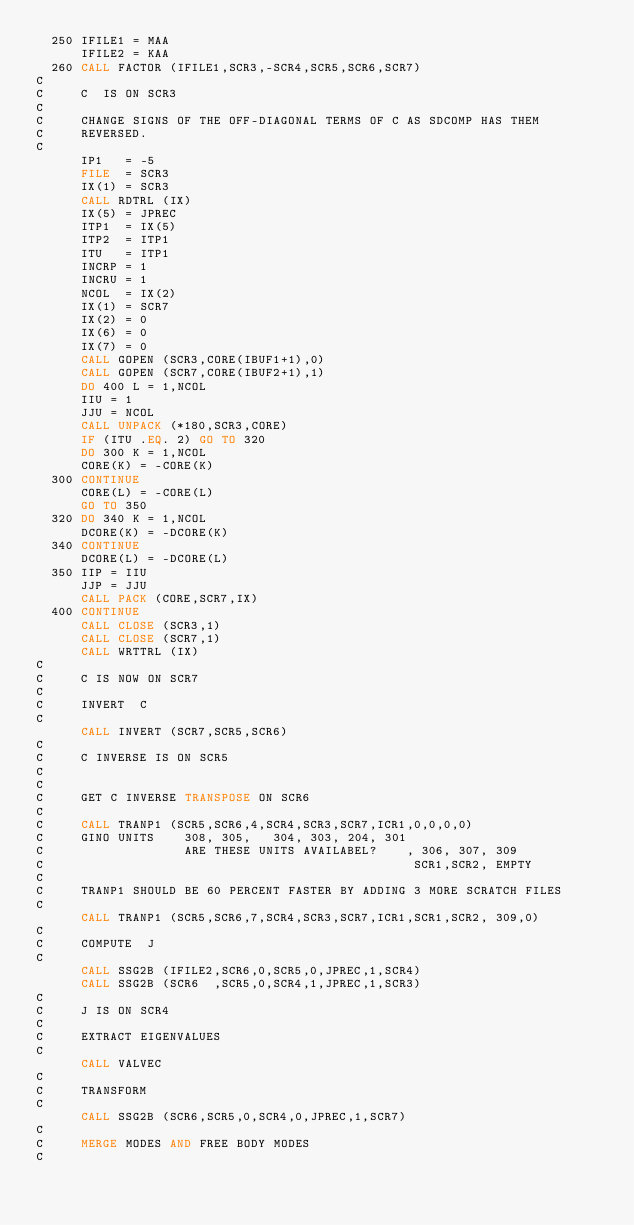Convert code to text. <code><loc_0><loc_0><loc_500><loc_500><_FORTRAN_>  250 IFILE1 = MAA
      IFILE2 = KAA
  260 CALL FACTOR (IFILE1,SCR3,-SCR4,SCR5,SCR6,SCR7)
C
C     C  IS ON SCR3
C
C     CHANGE SIGNS OF THE OFF-DIAGONAL TERMS OF C AS SDCOMP HAS THEM
C     REVERSED.
C
      IP1   = -5
      FILE  = SCR3
      IX(1) = SCR3
      CALL RDTRL (IX)
      IX(5) = JPREC
      ITP1  = IX(5)
      ITP2  = ITP1
      ITU   = ITP1
      INCRP = 1
      INCRU = 1
      NCOL  = IX(2)
      IX(1) = SCR7
      IX(2) = 0
      IX(6) = 0
      IX(7) = 0
      CALL GOPEN (SCR3,CORE(IBUF1+1),0)
      CALL GOPEN (SCR7,CORE(IBUF2+1),1)
      DO 400 L = 1,NCOL
      IIU = 1
      JJU = NCOL
      CALL UNPACK (*180,SCR3,CORE)
      IF (ITU .EQ. 2) GO TO 320
      DO 300 K = 1,NCOL
      CORE(K) = -CORE(K)
  300 CONTINUE
      CORE(L) = -CORE(L)
      GO TO 350
  320 DO 340 K = 1,NCOL
      DCORE(K) = -DCORE(K)
  340 CONTINUE
      DCORE(L) = -DCORE(L)
  350 IIP = IIU
      JJP = JJU
      CALL PACK (CORE,SCR7,IX)
  400 CONTINUE
      CALL CLOSE (SCR3,1)
      CALL CLOSE (SCR7,1)
      CALL WRTTRL (IX)
C
C     C IS NOW ON SCR7
C
C     INVERT  C
C
      CALL INVERT (SCR7,SCR5,SCR6)
C
C     C INVERSE IS ON SCR5
C
C
C     GET C INVERSE TRANSPOSE ON SCR6
C
C     CALL TRANP1 (SCR5,SCR6,4,SCR4,SCR3,SCR7,ICR1,0,0,0,0)
C     GINO UNITS    308, 305,   304, 303, 204, 301
C                   ARE THESE UNITS AVAILABEL?    , 306, 307, 309
C                                                  SCR1,SCR2, EMPTY
C
C     TRANP1 SHOULD BE 60 PERCENT FASTER BY ADDING 3 MORE SCRATCH FILES
C
      CALL TRANP1 (SCR5,SCR6,7,SCR4,SCR3,SCR7,ICR1,SCR1,SCR2, 309,0)
C
C     COMPUTE  J
C
      CALL SSG2B (IFILE2,SCR6,0,SCR5,0,JPREC,1,SCR4)
      CALL SSG2B (SCR6  ,SCR5,0,SCR4,1,JPREC,1,SCR3)
C
C     J IS ON SCR4
C
C     EXTRACT EIGENVALUES
C
      CALL VALVEC
C
C     TRANSFORM
C
      CALL SSG2B (SCR6,SCR5,0,SCR4,0,JPREC,1,SCR7)
C
C     MERGE MODES AND FREE BODY MODES
C</code> 